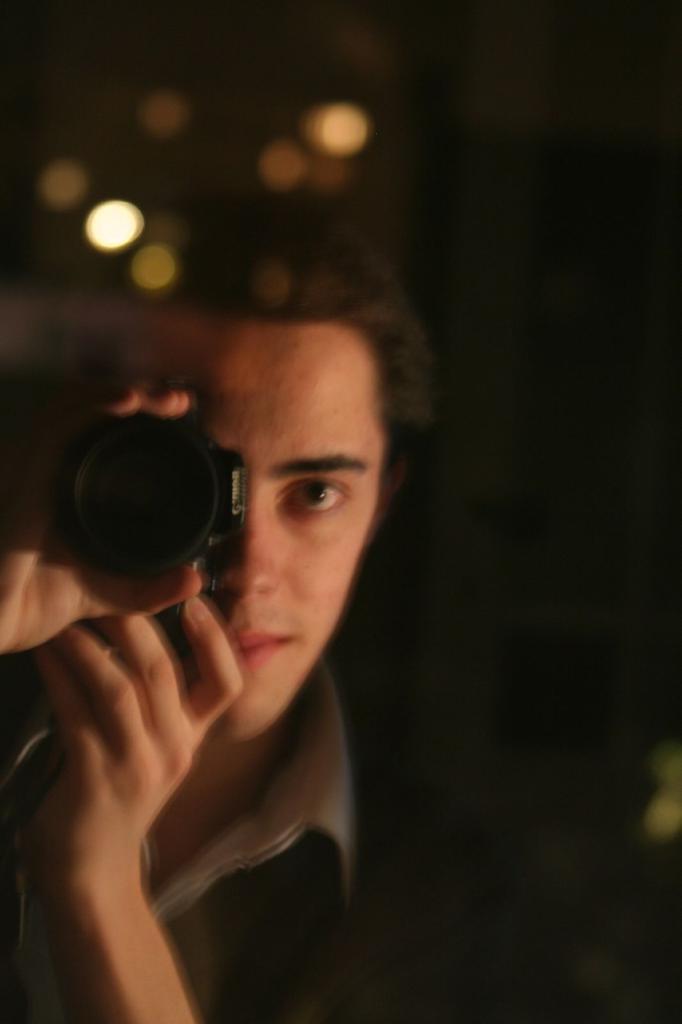Can you describe this image briefly? This image consists of a person who is holding a camera near his eye. There are light on the top. He is smiling. 